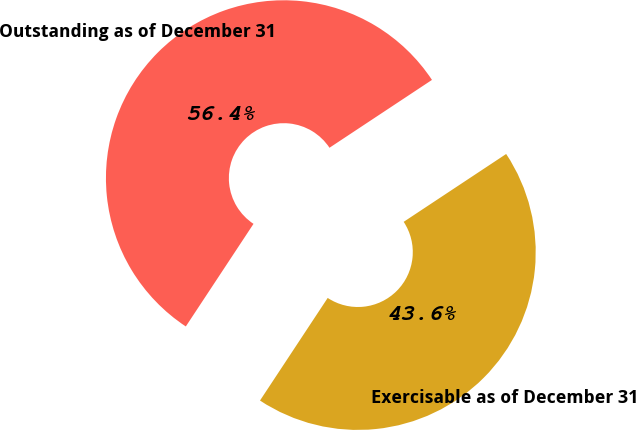Convert chart to OTSL. <chart><loc_0><loc_0><loc_500><loc_500><pie_chart><fcel>Outstanding as of December 31<fcel>Exercisable as of December 31<nl><fcel>56.41%<fcel>43.59%<nl></chart> 